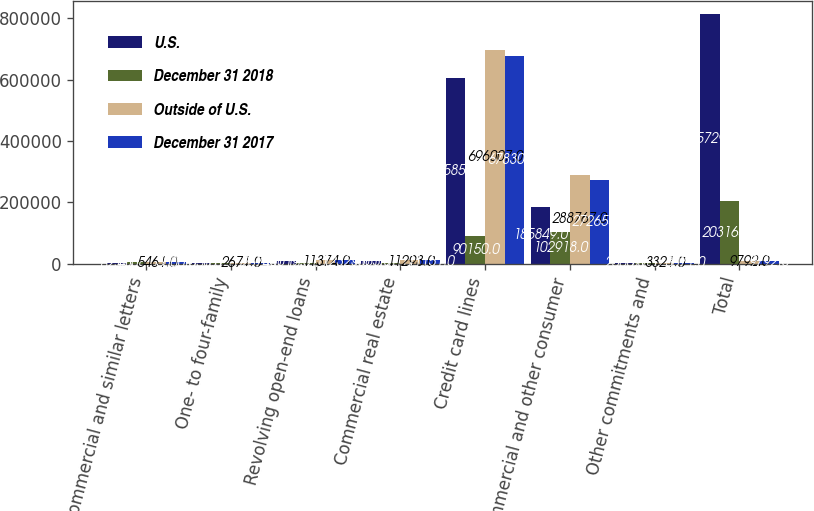Convert chart. <chart><loc_0><loc_0><loc_500><loc_500><stacked_bar_chart><ecel><fcel>Commercial and similar letters<fcel>One- to four-family<fcel>Revolving open-end loans<fcel>Commercial real estate<fcel>Credit card lines<fcel>Commercial and other consumer<fcel>Other commitments and<fcel>Total<nl><fcel>U.S.<fcel>823<fcel>1056<fcel>10019<fcel>9565<fcel>605857<fcel>185849<fcel>2560<fcel>815729<nl><fcel>December 31 2018<fcel>4638<fcel>1615<fcel>1355<fcel>1728<fcel>90150<fcel>102918<fcel>761<fcel>203165<nl><fcel>Outside of U.S.<fcel>5461<fcel>2671<fcel>11374<fcel>11293<fcel>696007<fcel>288767<fcel>3321<fcel>9792<nl><fcel>December 31 2017<fcel>5000<fcel>2674<fcel>12323<fcel>11151<fcel>678300<fcel>272655<fcel>3071<fcel>9792<nl></chart> 